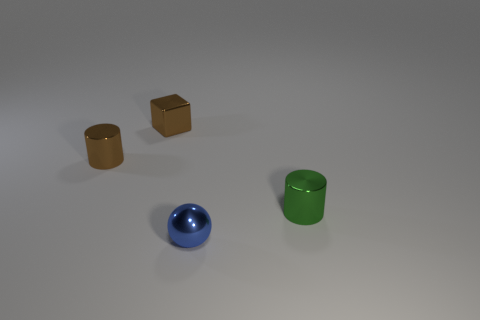How would you describe the overall composition of objects in this image? The image presents a simple, still life composition consisting of four objects placed on a flat surface. Two of the objects are cube-shaped blocks that appear to be made of a matte, possibly wooden material. There is also a pair of cylindrical objects with reflective surfaces, suggesting they might be metallic. The placement of these objects creates a balanced and symmetrical arrangement on the surface. 